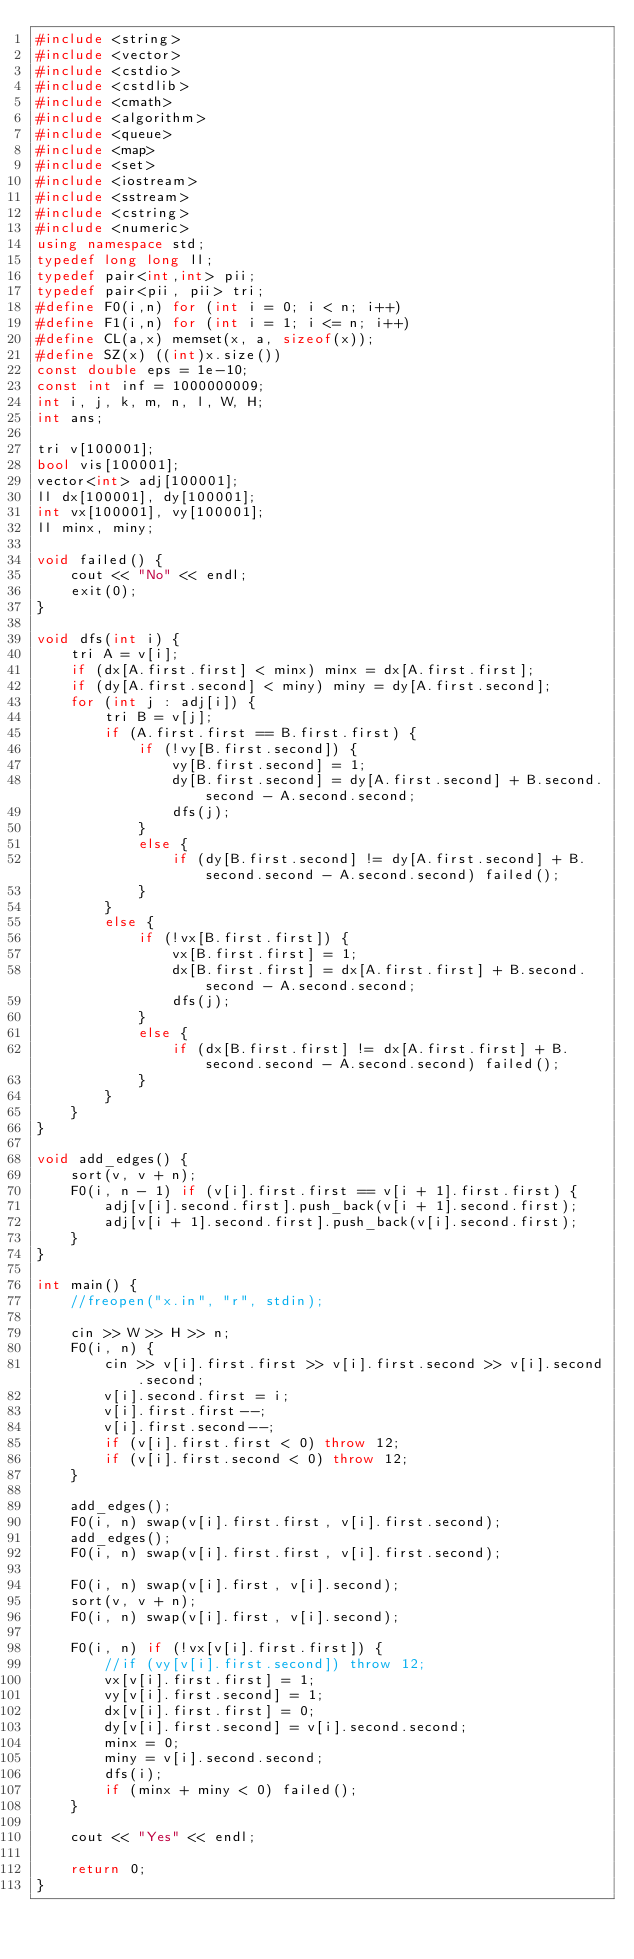<code> <loc_0><loc_0><loc_500><loc_500><_C++_>#include <string>
#include <vector>
#include <cstdio>
#include <cstdlib>
#include <cmath>
#include <algorithm>
#include <queue>
#include <map>
#include <set>
#include <iostream>
#include <sstream>
#include <cstring>
#include <numeric>
using namespace std;
typedef long long ll;
typedef pair<int,int> pii;
typedef pair<pii, pii> tri;
#define F0(i,n) for (int i = 0; i < n; i++)
#define F1(i,n) for (int i = 1; i <= n; i++)
#define CL(a,x) memset(x, a, sizeof(x));
#define SZ(x) ((int)x.size())
const double eps = 1e-10;
const int inf = 1000000009;
int i, j, k, m, n, l, W, H;
int ans;

tri v[100001];
bool vis[100001];
vector<int> adj[100001];
ll dx[100001], dy[100001];
int vx[100001], vy[100001];
ll minx, miny;

void failed() {
	cout << "No" << endl;
	exit(0);
}

void dfs(int i) {
	tri A = v[i];
	if (dx[A.first.first] < minx) minx = dx[A.first.first];
	if (dy[A.first.second] < miny) miny = dy[A.first.second];
	for (int j : adj[i]) {
		tri B = v[j];
		if (A.first.first == B.first.first) {
			if (!vy[B.first.second]) {
				vy[B.first.second] = 1;
				dy[B.first.second] = dy[A.first.second] + B.second.second - A.second.second;
				dfs(j);
			}
			else {
				if (dy[B.first.second] != dy[A.first.second] + B.second.second - A.second.second) failed();
			}
		}
		else {
			if (!vx[B.first.first]) {
				vx[B.first.first] = 1;
				dx[B.first.first] = dx[A.first.first] + B.second.second - A.second.second;
				dfs(j);
			}
			else {
				if (dx[B.first.first] != dx[A.first.first] + B.second.second - A.second.second) failed();
			}
		}
	}
}

void add_edges() {
	sort(v, v + n);
	F0(i, n - 1) if (v[i].first.first == v[i + 1].first.first) {
		adj[v[i].second.first].push_back(v[i + 1].second.first);
		adj[v[i + 1].second.first].push_back(v[i].second.first);
	}
}

int main() {
	//freopen("x.in", "r", stdin);
	
	cin >> W >> H >> n;
	F0(i, n) {
		cin >> v[i].first.first >> v[i].first.second >> v[i].second.second;
		v[i].second.first = i;
		v[i].first.first--;
		v[i].first.second--;
		if (v[i].first.first < 0) throw 12;
		if (v[i].first.second < 0) throw 12;
	}

	add_edges();
	F0(i, n) swap(v[i].first.first, v[i].first.second);
	add_edges();
	F0(i, n) swap(v[i].first.first, v[i].first.second);

	F0(i, n) swap(v[i].first, v[i].second);
	sort(v, v + n);
	F0(i, n) swap(v[i].first, v[i].second);

	F0(i, n) if (!vx[v[i].first.first]) {
		//if (vy[v[i].first.second]) throw 12;
		vx[v[i].first.first] = 1;
		vy[v[i].first.second] = 1;
		dx[v[i].first.first] = 0;
		dy[v[i].first.second] = v[i].second.second;
		minx = 0;
		miny = v[i].second.second;
		dfs(i);
		if (minx + miny < 0) failed();
	}

	cout << "Yes" << endl;

	return 0;
}
</code> 